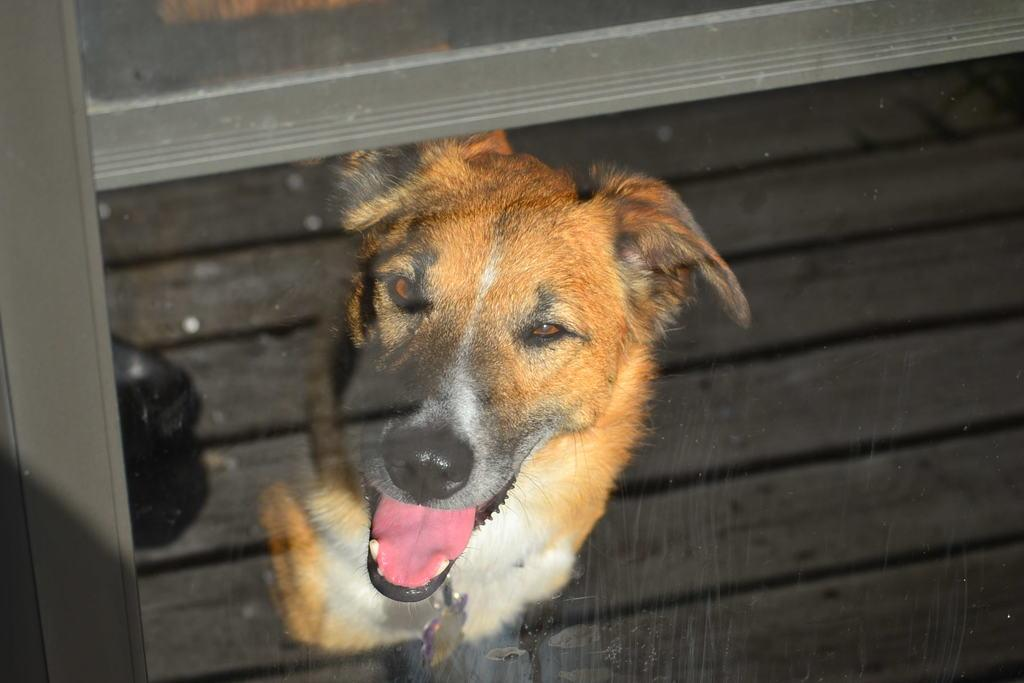What type of structure can be seen in the image? There is a glass window in the image. What can be seen through the glass window? A dog is visible through the window. Can you describe the appearance of the dog? The dog is light brown in color, and some parts of the dog are white. Is there a bag that exists on the road in the image? There is no mention of a bag or a road in the image, so it cannot be determined if a bag exists on the road. 